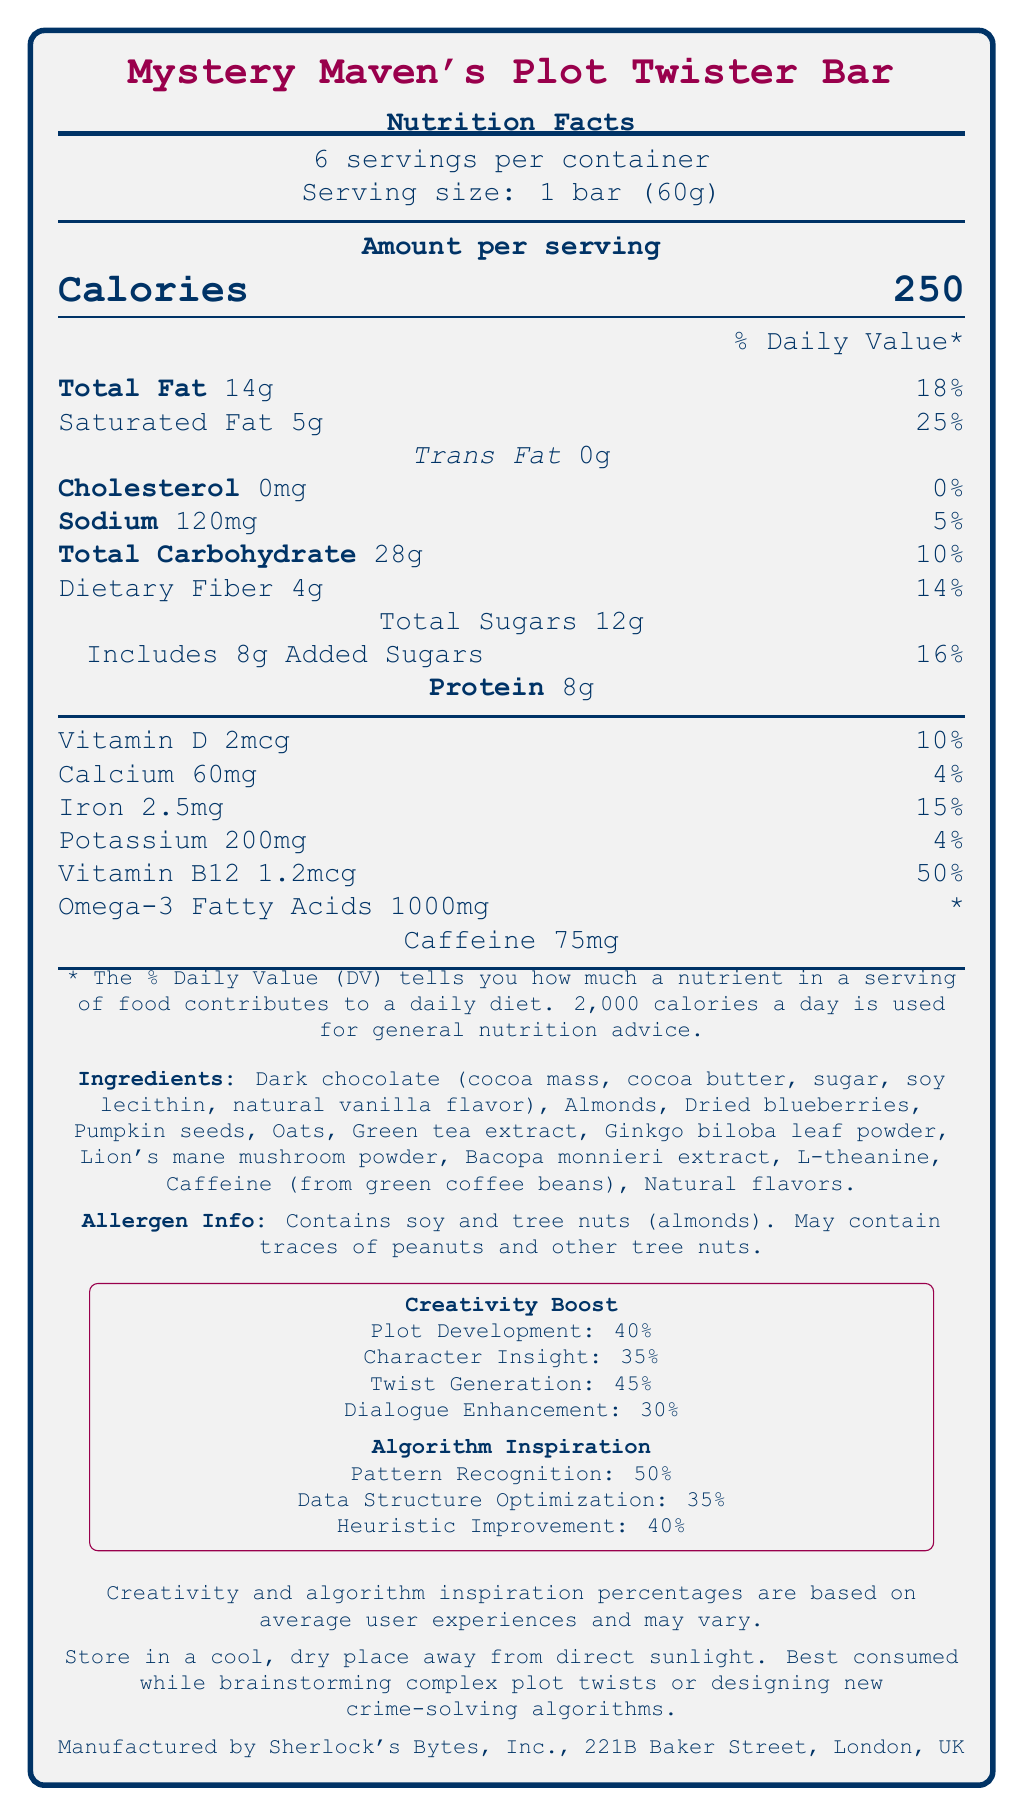what is the serving size? The document specifies that the serving size is 1 bar, which is equal to 60 grams.
Answer: 1 bar (60g) how many calories are in a serving? The document states that each serving of the Mystery Maven's Plot Twister Bar contains 250 calories.
Answer: 250 what are the total fats in one serving? The document indicates that one serving contains 14 grams of total fat.
Answer: 14g what percentage of the daily value is provided by the saturated fat in one serving? According to the document, the saturated fat in one serving is 5 grams, which is 25% of the daily value.
Answer: 25% how much protein is in a serving? The document shows that the amount of protein per serving is 8 grams.
Answer: 8g which ingredient is a source of caffeine? The list of ingredients mentions that caffeine is derived from green coffee beans.
Answer: Green coffee beans what is the daily value percentage for dietary fiber per serving? The document states that the dietary fiber in one serving is 4 grams, which is 14% of the daily value.
Answer: 14% which ingredient is **not** listed in the product? A. Pumpkin seeds B. Dark chocolate C. Avocados D. Almonds The document lists pumpkin seeds, dark chocolate, and almonds as ingredients, but not avocados.
Answer: C. Avocados which nutrient has the highest daily value percentage per serving? A. Vitamin D B. Calcium C. Iron D. Vitamin B12 Vitamin B12 has the highest daily value percentage per serving at 50%, as indicated in the document.
Answer: D. Vitamin B12 True or False: The product contains no tree nuts. The allergen information in the document clearly states that the product contains almonds, which are tree nuts.
Answer: False summarize the main idea of the document. The document provides comprehensive information about the nutritional profile of the snack bar, including key nutrients, ingredients, and suggested uses for enhancing creativity and developing crime-solving algorithms.
Answer: The document presents the nutritional facts for Mystery Maven's Plot Twister Bar, a snack bar designed to enhance creativity and provide algorithm inspiration. It includes details on serving size, nutritional content, ingredients, and allergen information, along with its manufactured location and storage instructions. what is the address of the manufacturer? The manufacturer is listed as Sherlock's Bytes, Inc., located at 221B Baker Street, London, UK.
Answer: 221B Baker Street, London, UK how much sodium is in one serving? The document specifies that there are 120 milligrams of sodium in one serving.
Answer: 120mg how many servings are in the container? The document indicates that each container has 6 servings.
Answer: 6 servings which benefit has the highest percentage under "Creativity Boost"? The document states that twist generation has a 45% boost under the creativity category.
Answer: Twist Generation: 45% how should the product be stored? The document advises to store the product in a cool, dry place away from direct sunlight.
Answer: Store in a cool, dry place, away from direct sunlight. what are the sources of Omega-3 fatty acids in the bar? The document specifies the amount of Omega-3 fatty acids but does not list the source ingredients containing Omega-3s.
Answer: Cannot be determined 